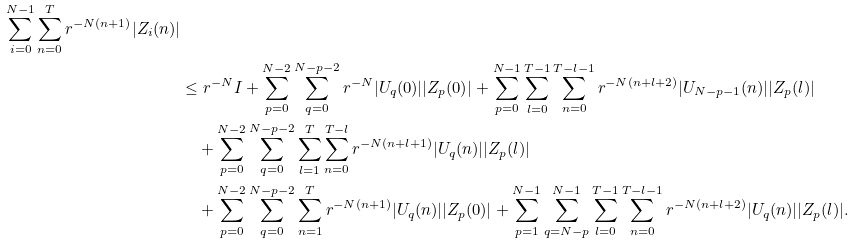<formula> <loc_0><loc_0><loc_500><loc_500>{ \sum _ { i = 0 } ^ { N - 1 } \sum _ { n = 0 } ^ { T } r ^ { - N ( n + 1 ) } | Z _ { i } ( n ) | } \\ & \leq r ^ { - N } I + \sum _ { p = 0 } ^ { N - 2 } \sum _ { q = 0 } ^ { N - p - 2 } r ^ { - N } | U _ { q } ( 0 ) | | Z _ { p } ( 0 ) | + \sum _ { p = 0 } ^ { N - 1 } \sum _ { l = 0 } ^ { T - 1 } \sum _ { n = 0 } ^ { T - l - 1 } r ^ { - N ( n + l + 2 ) } | U _ { N - p - 1 } ( n ) | | Z _ { p } ( l ) | \\ & \quad + \sum _ { p = 0 } ^ { N - 2 } \sum _ { q = 0 } ^ { N - p - 2 } \sum _ { l = 1 } ^ { T } \sum _ { n = 0 } ^ { T - l } r ^ { - N ( n + l + 1 ) } | U _ { q } ( n ) | | Z _ { p } ( l ) | \\ & \quad + \sum _ { p = 0 } ^ { N - 2 } \sum _ { q = 0 } ^ { N - p - 2 } \sum _ { n = 1 } ^ { T } r ^ { - N ( n + 1 ) } | U _ { q } ( n ) | | Z _ { p } ( 0 ) | + \sum _ { p = 1 } ^ { N - 1 } \sum _ { q = N - p } ^ { N - 1 } \sum _ { l = 0 } ^ { T - 1 } \sum _ { n = 0 } ^ { T - l - 1 } r ^ { - N ( n + l + 2 ) } | U _ { q } ( n ) | | Z _ { p } ( l ) | .</formula> 